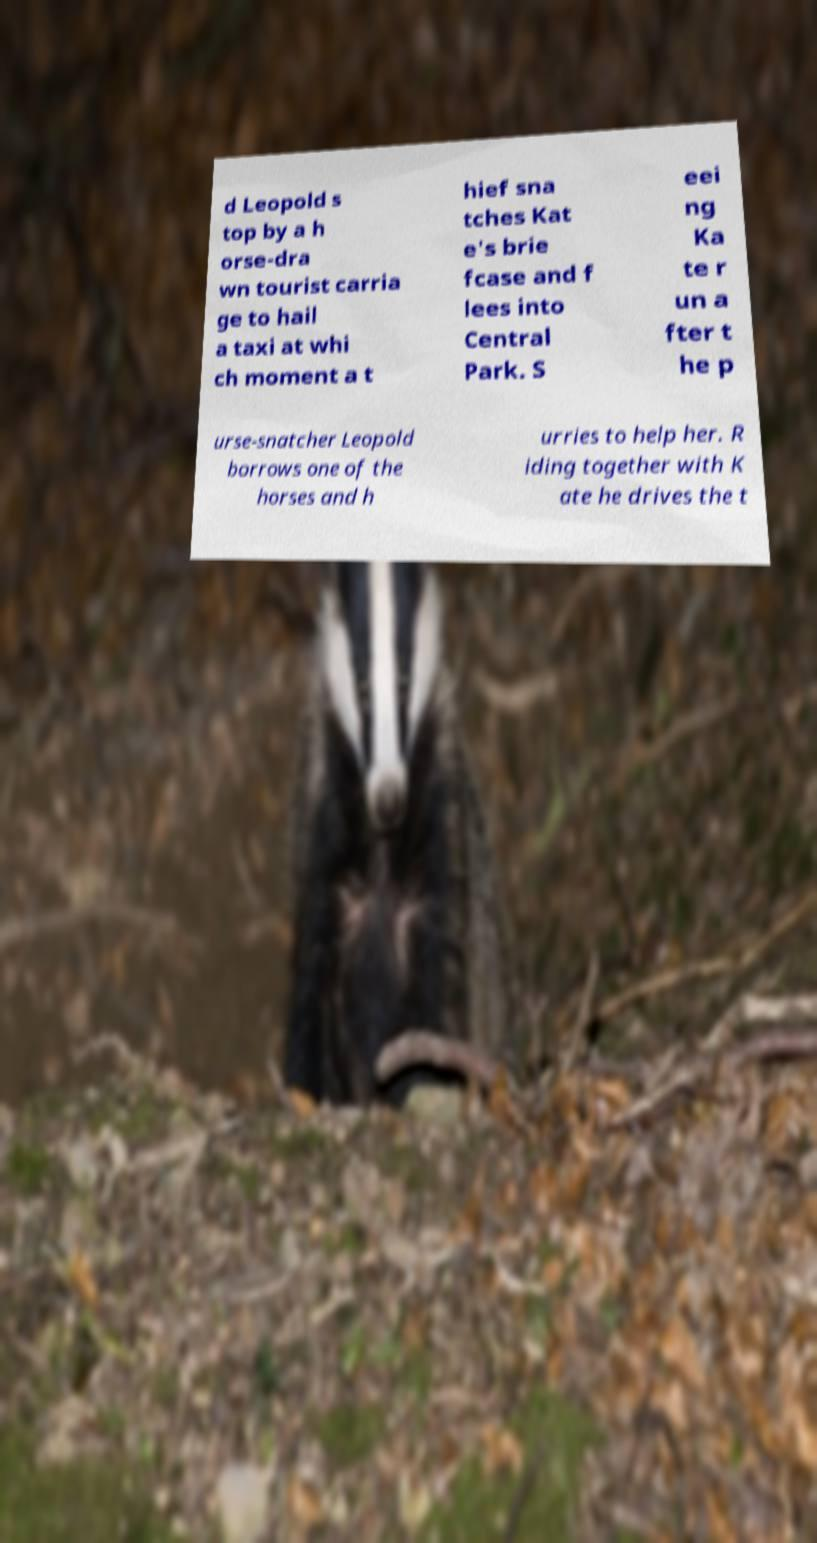What messages or text are displayed in this image? I need them in a readable, typed format. d Leopold s top by a h orse-dra wn tourist carria ge to hail a taxi at whi ch moment a t hief sna tches Kat e's brie fcase and f lees into Central Park. S eei ng Ka te r un a fter t he p urse-snatcher Leopold borrows one of the horses and h urries to help her. R iding together with K ate he drives the t 